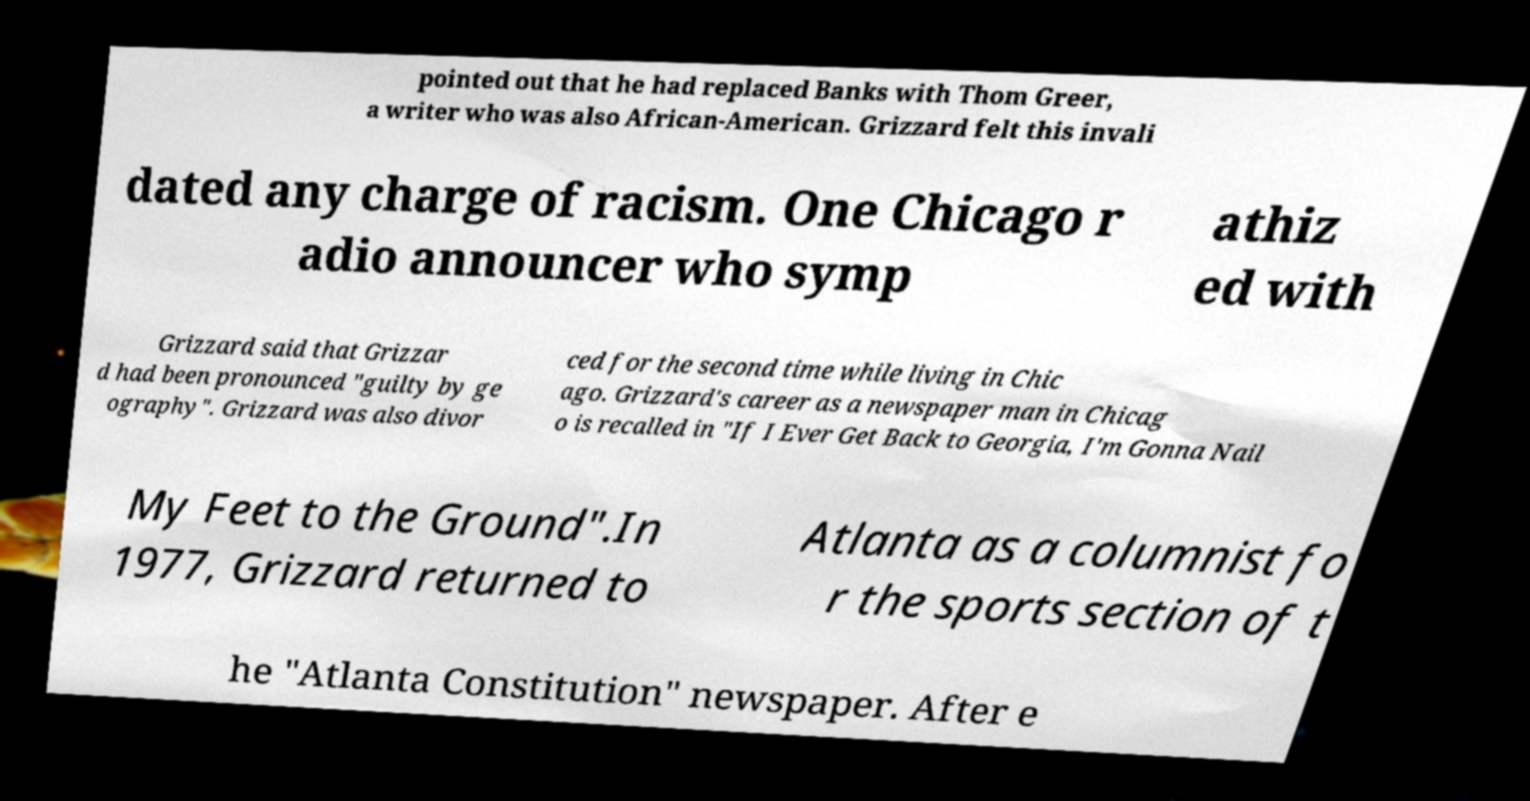Can you accurately transcribe the text from the provided image for me? pointed out that he had replaced Banks with Thom Greer, a writer who was also African-American. Grizzard felt this invali dated any charge of racism. One Chicago r adio announcer who symp athiz ed with Grizzard said that Grizzar d had been pronounced "guilty by ge ography". Grizzard was also divor ced for the second time while living in Chic ago. Grizzard's career as a newspaper man in Chicag o is recalled in "If I Ever Get Back to Georgia, I'm Gonna Nail My Feet to the Ground".In 1977, Grizzard returned to Atlanta as a columnist fo r the sports section of t he "Atlanta Constitution" newspaper. After e 